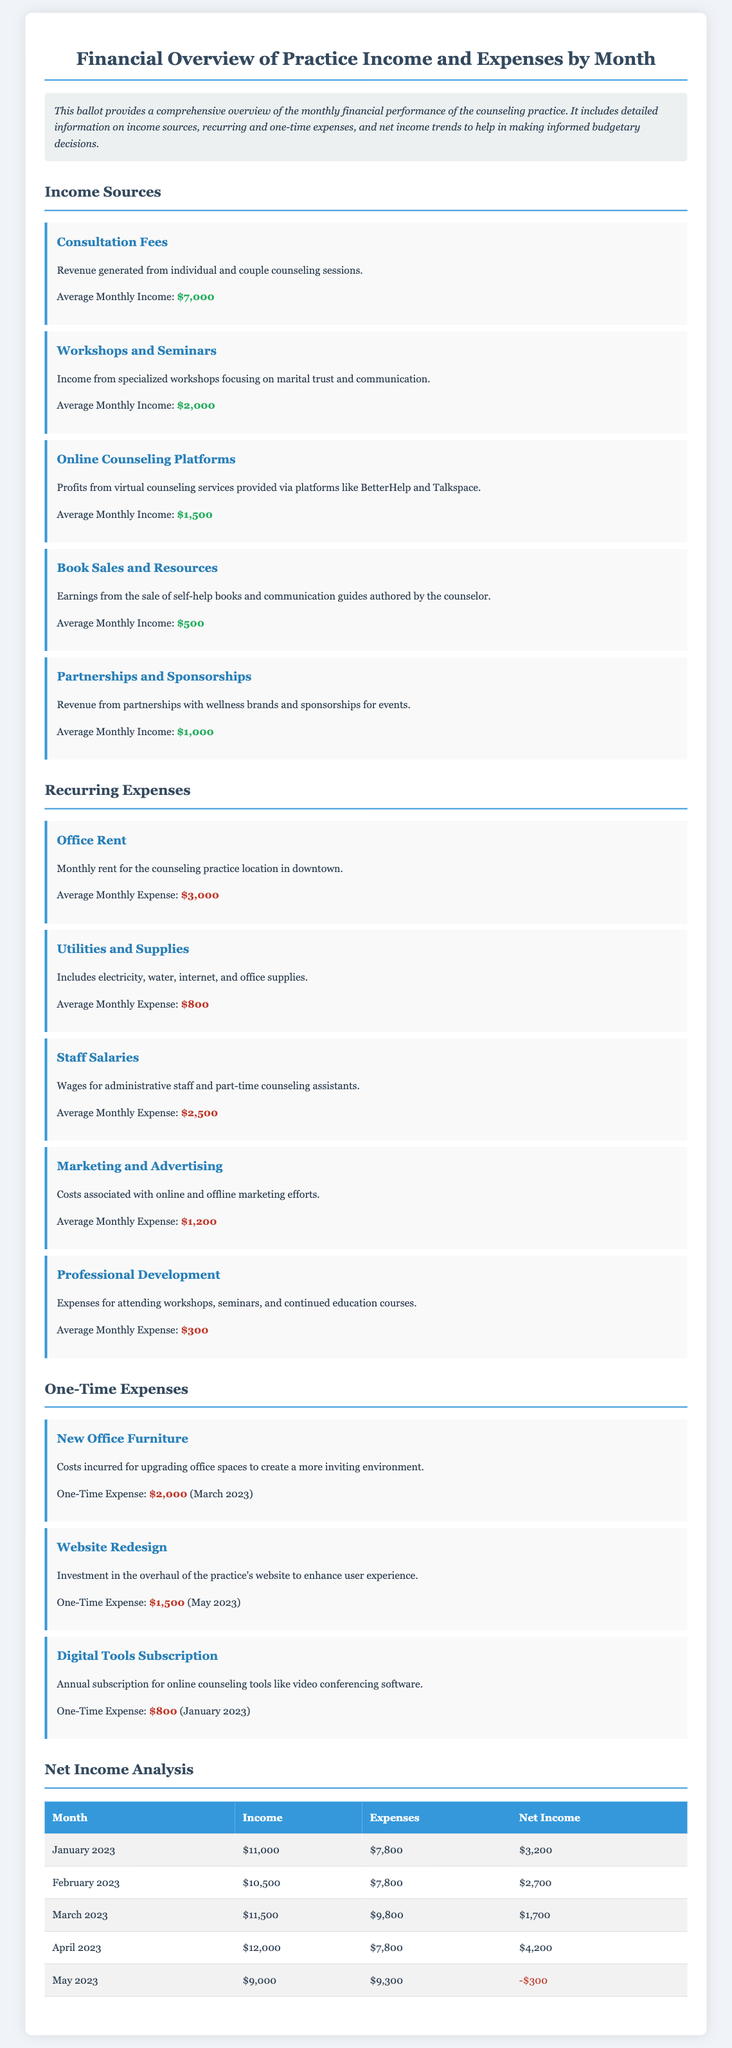What is the average monthly income from consultation fees? The average monthly income from consultation fees is listed in the document.
Answer: $7,000 What is the one-time expense for new office furniture? The document states the amount for the new office furniture incurred in March 2023.
Answer: $2,000 Which month had the highest net income? The comparison of net income for each month reveals which one is the highest.
Answer: April 2023 What is the average monthly expense for staff salaries? The document provides a specific average monthly expense for staff salaries.
Answer: $2,500 What type of income is generated from workshops and seminars? The document specifies the type of income generated from workshops focusing on marital trust and communication.
Answer: Workshops and Seminars Which month had a negative net income? The net income analysis table indicates a month where the net income was negative.
Answer: May 2023 What is the total average monthly income from all sources? The total income can be obtained by adding all average monthly incomes listed.
Answer: $12,000 What is the recurring expense for utilities and supplies? The document specifies the average monthly expense for utilities and supplies.
Answer: $800 What was the total expense for the month of February 2023? The net income analysis table shows the total expense for February 2023 specifically.
Answer: $7,800 